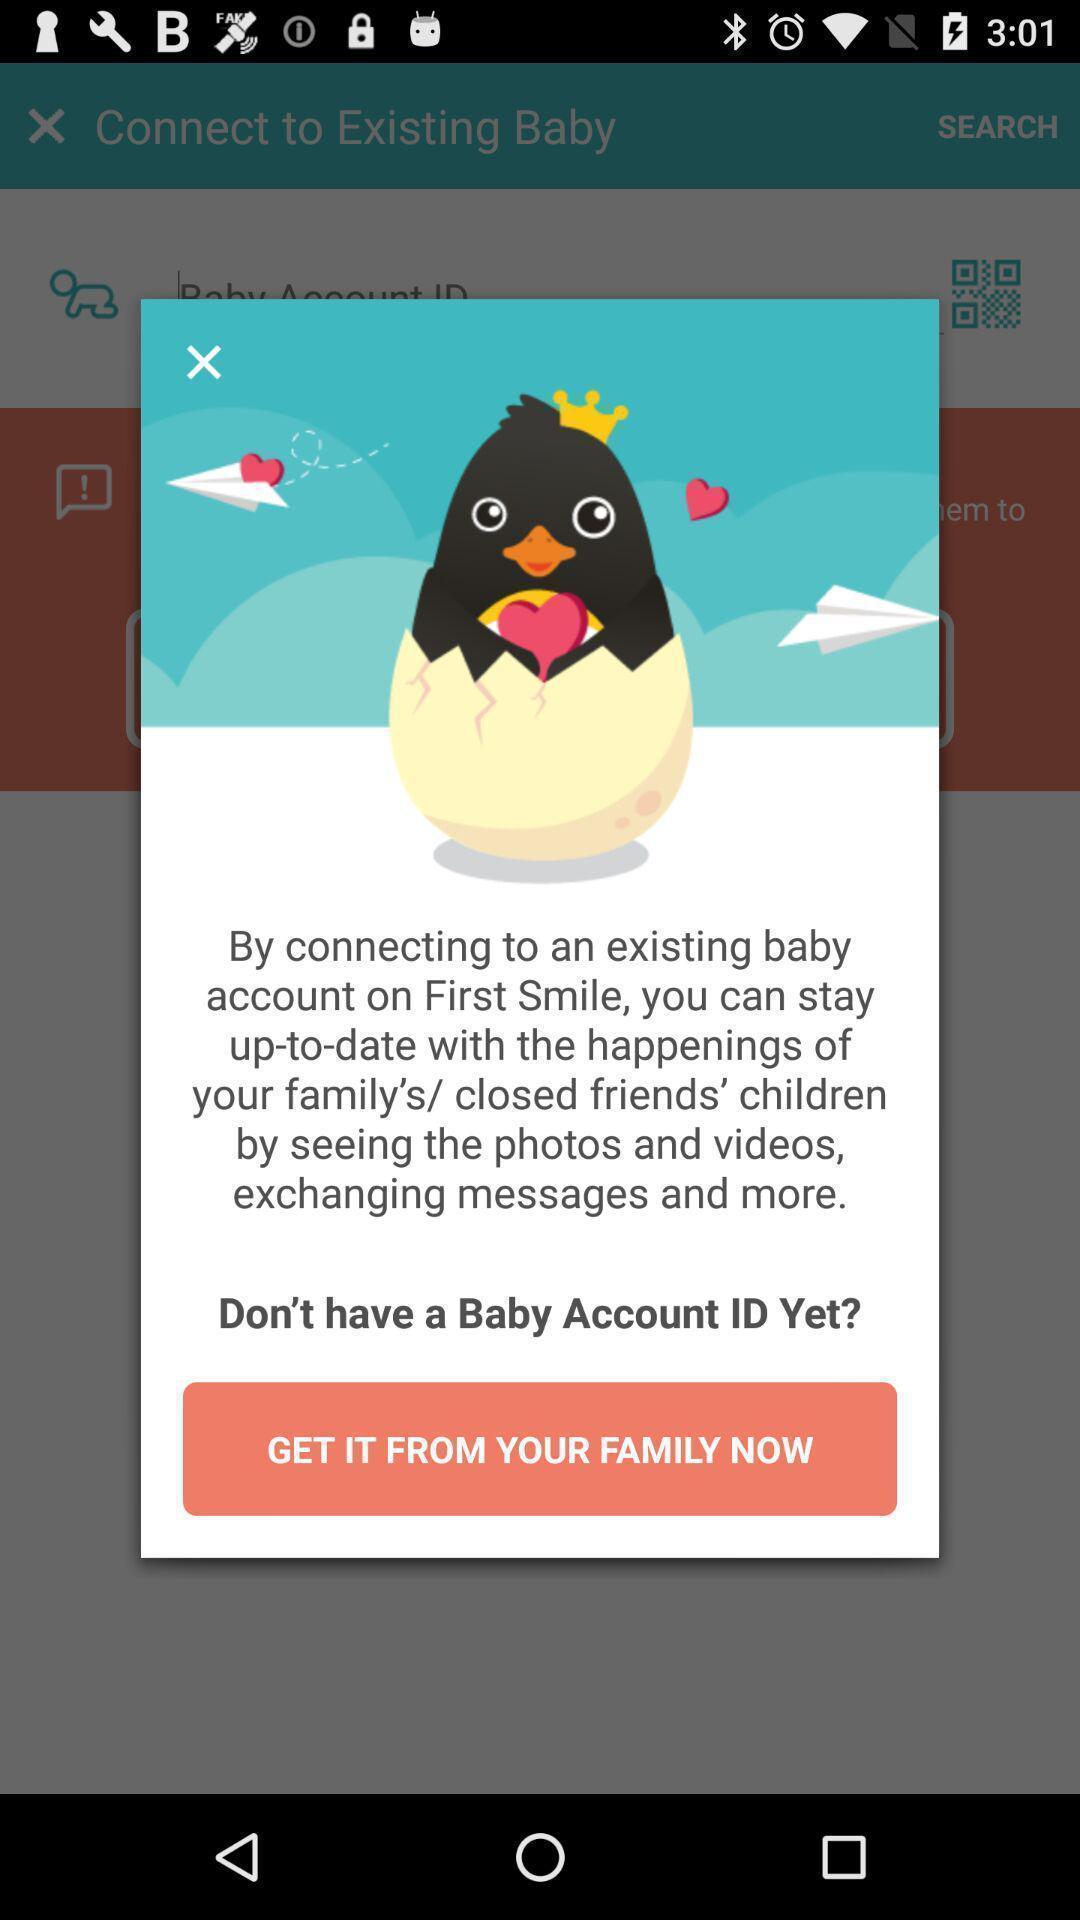Tell me what you see in this picture. Welcome page of a baby app. 